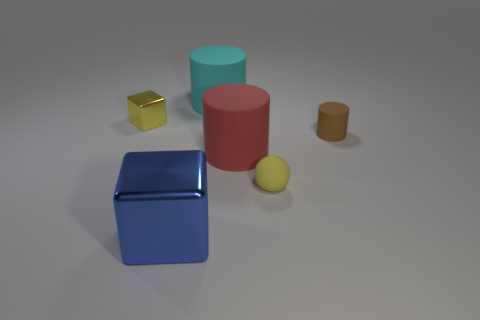How would you describe the lighting and shadows in the scene? The lighting in the scene is soft and diffuse, coming from above as indicated by the gentle shadows cast directly under the objects. The even lighting suggests an artificial or studio light setup, which creates a calm and clear visibility for all objects in the image. 